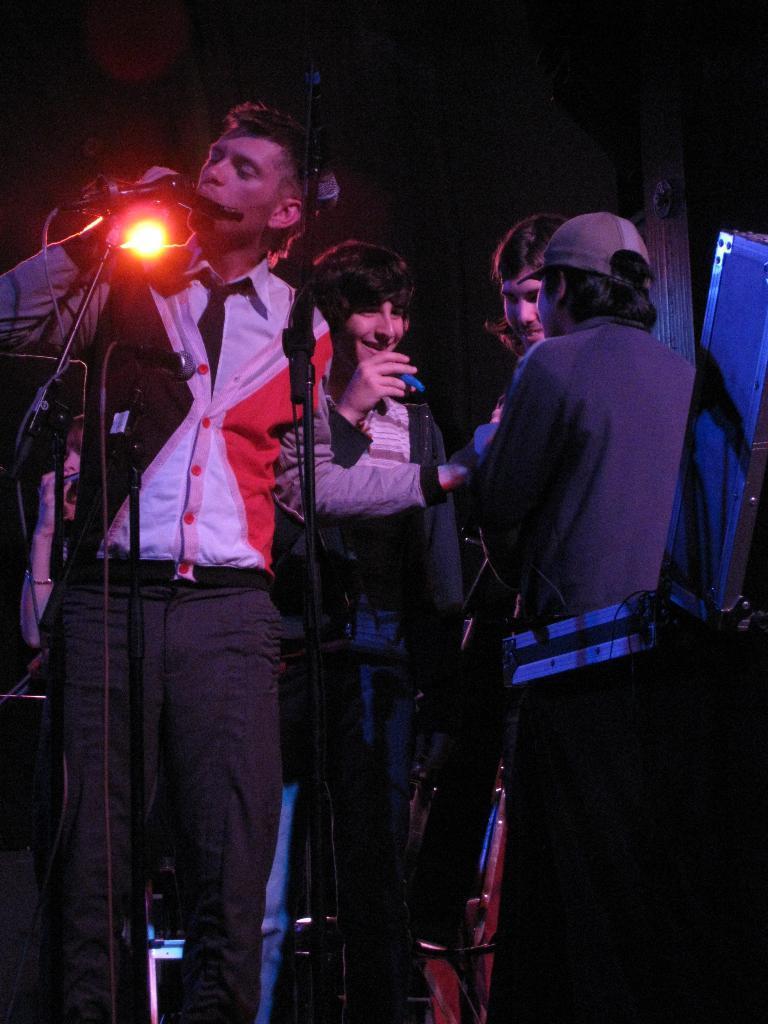Could you give a brief overview of what you see in this image? There is a group of a people. They are standing on a stage. They are playing a musical instruments. In the center we have a person. He is holding a mic. He is talking. On the right side we have a another person. He is wearing a cap. on the left side we have a white color shirt person. He is holding a mic. 